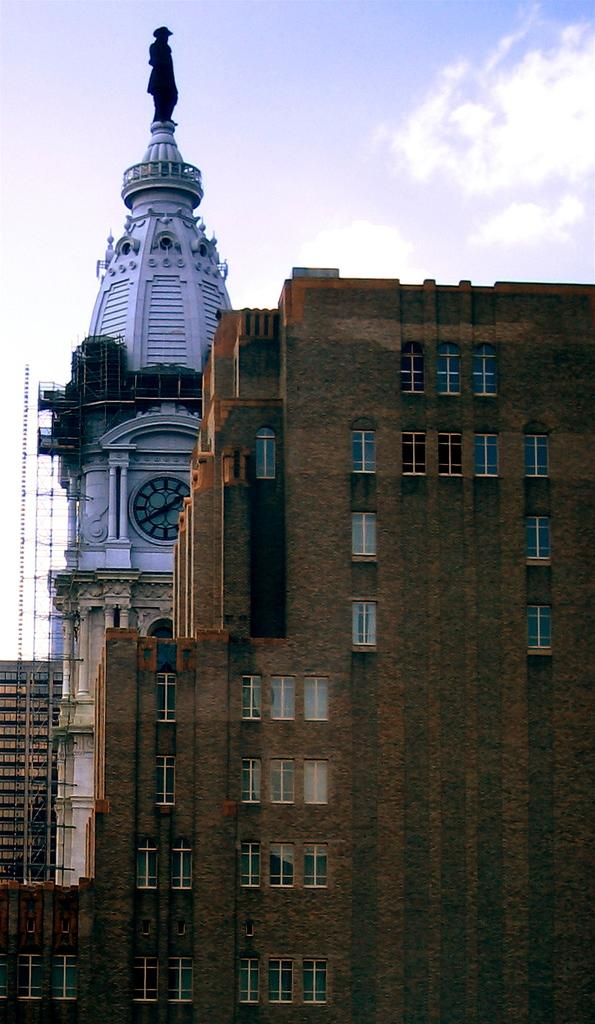What type of structures can be seen in the image? There are buildings in the image. Can you describe the white color building in the image? The white color building has a sculpture, windows, and a grille. What is visible in the background of the image? The sky with clouds is visible in the background of the image. What year is the drain located in the image? There is no drain present in the image. How many laborers are working on the white color building in the image? There are no laborers visible in the image. 